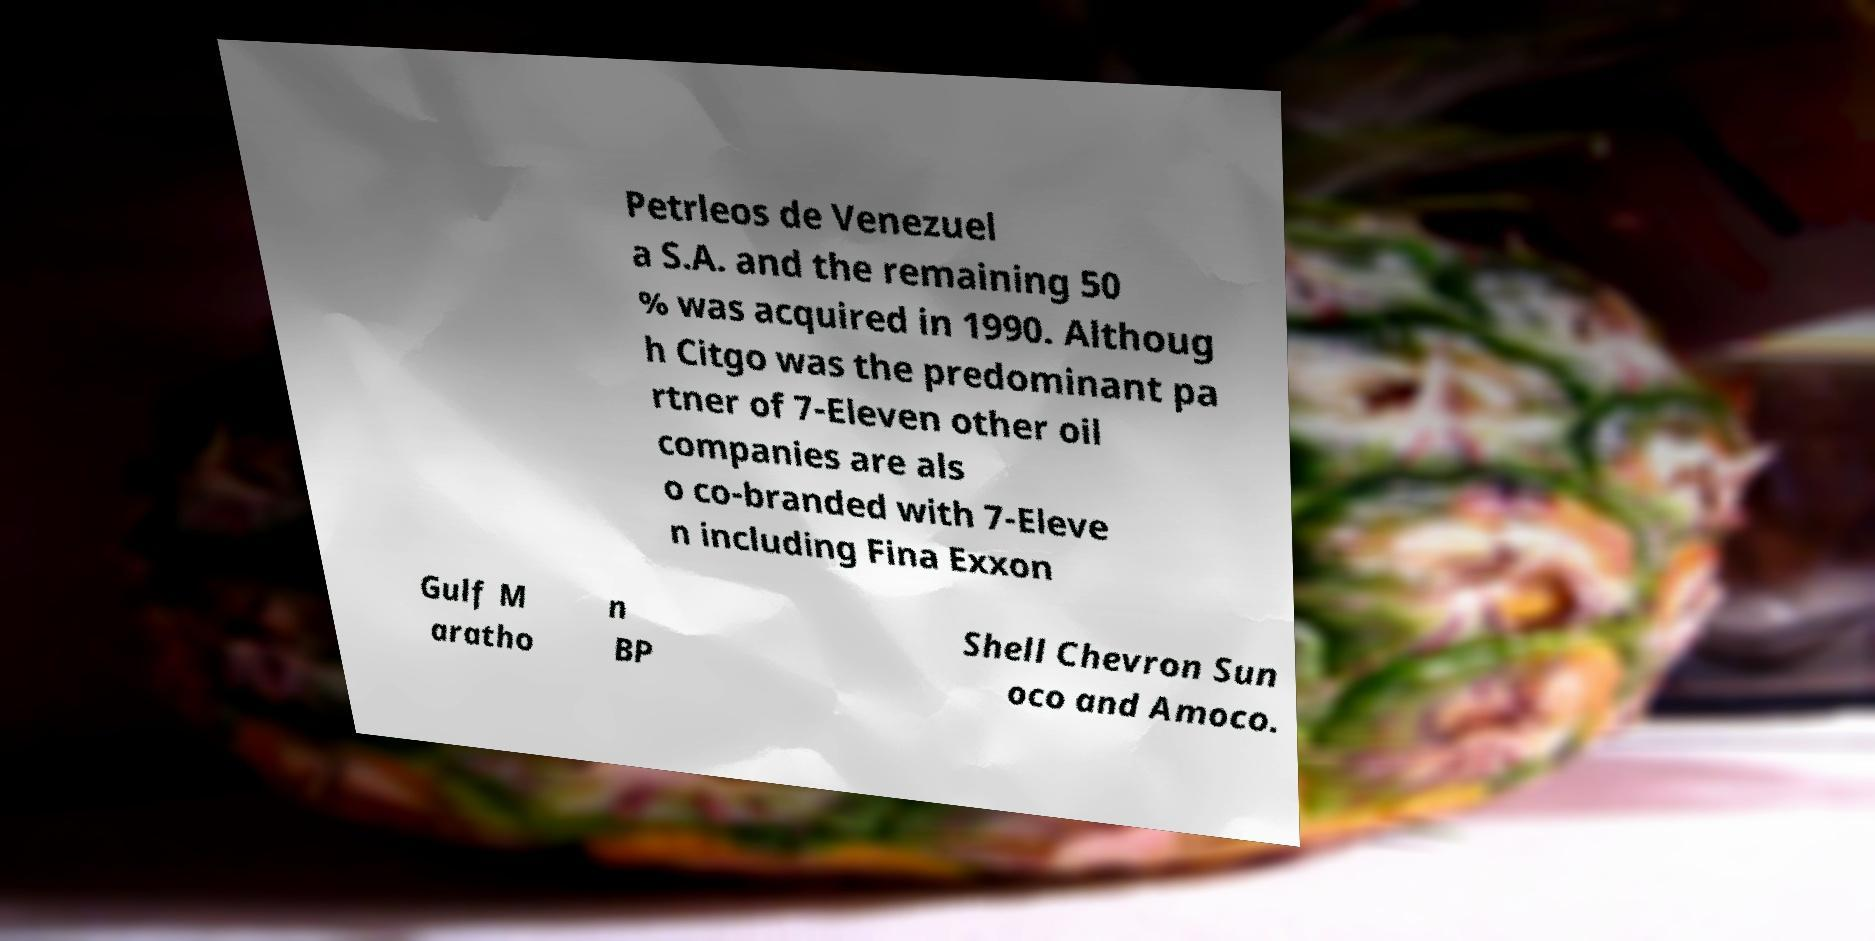I need the written content from this picture converted into text. Can you do that? Petrleos de Venezuel a S.A. and the remaining 50 % was acquired in 1990. Althoug h Citgo was the predominant pa rtner of 7-Eleven other oil companies are als o co-branded with 7-Eleve n including Fina Exxon Gulf M aratho n BP Shell Chevron Sun oco and Amoco. 